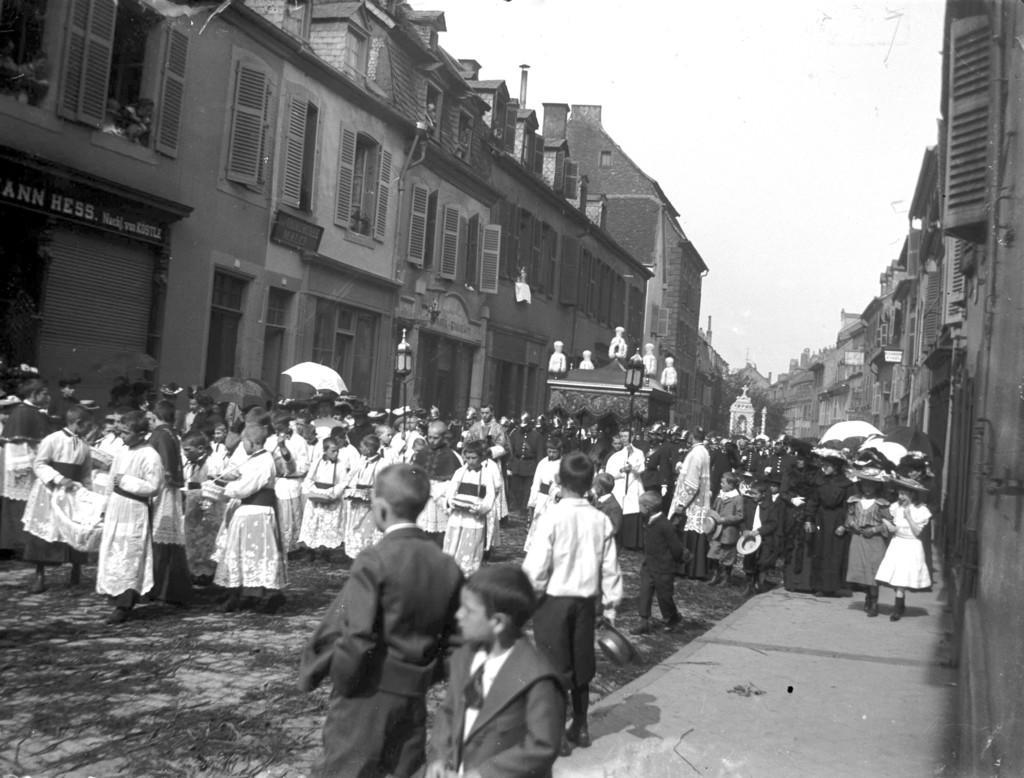Can you describe this image briefly? On the left side, there are persons on a road. Some of them are holding umbrellas. On the right side, there are persons on a footpath. Beside this footpath, there are buildings. In the background, there are buildings, trees and there are clouds in the sky. 